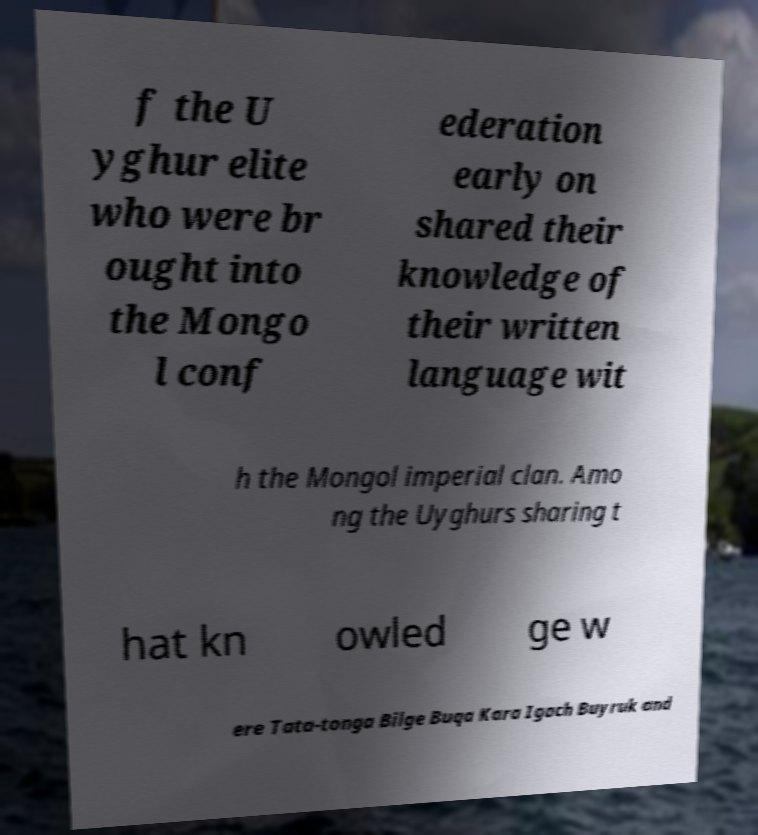Can you read and provide the text displayed in the image?This photo seems to have some interesting text. Can you extract and type it out for me? f the U yghur elite who were br ought into the Mongo l conf ederation early on shared their knowledge of their written language wit h the Mongol imperial clan. Amo ng the Uyghurs sharing t hat kn owled ge w ere Tata-tonga Bilge Buqa Kara Igach Buyruk and 